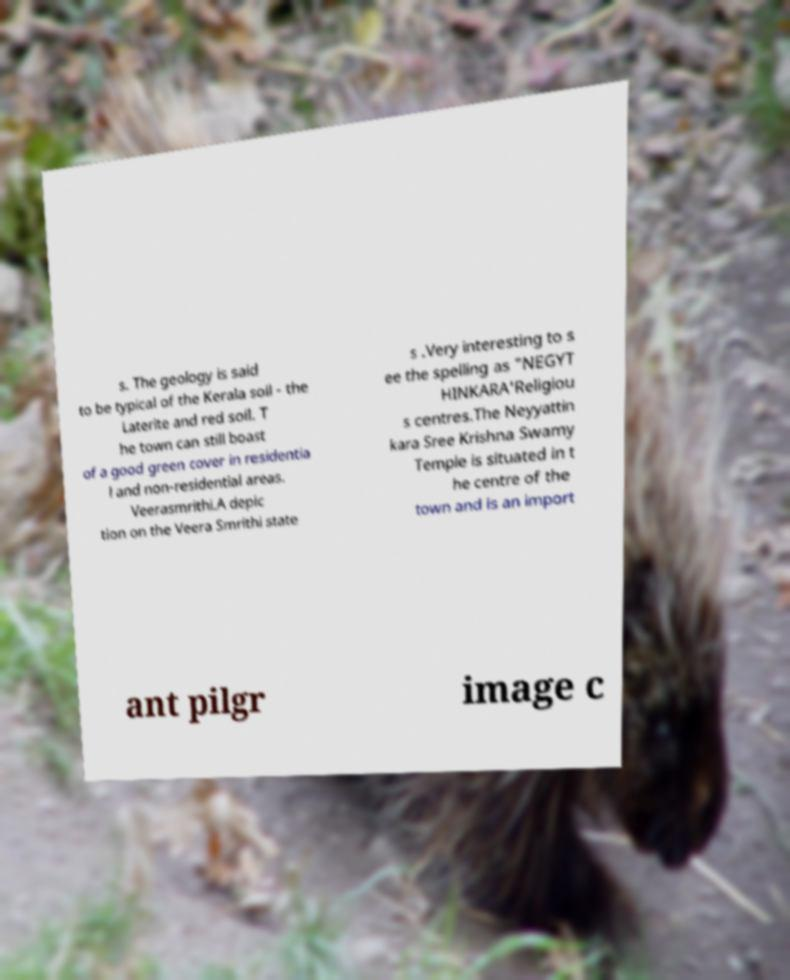Please identify and transcribe the text found in this image. s. The geology is said to be typical of the Kerala soil - the Laterite and red soil. T he town can still boast of a good green cover in residentia l and non-residential areas. Veerasmrithi.A depic tion on the Veera Smrithi state s .Very interesting to s ee the spelling as "NEGYT HINKARA'Religiou s centres.The Neyyattin kara Sree Krishna Swamy Temple is situated in t he centre of the town and is an import ant pilgr image c 